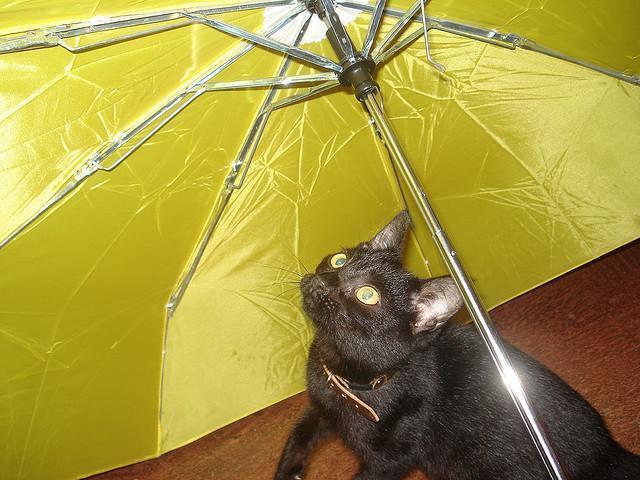How many umbrellas are there?
Give a very brief answer. 1. 